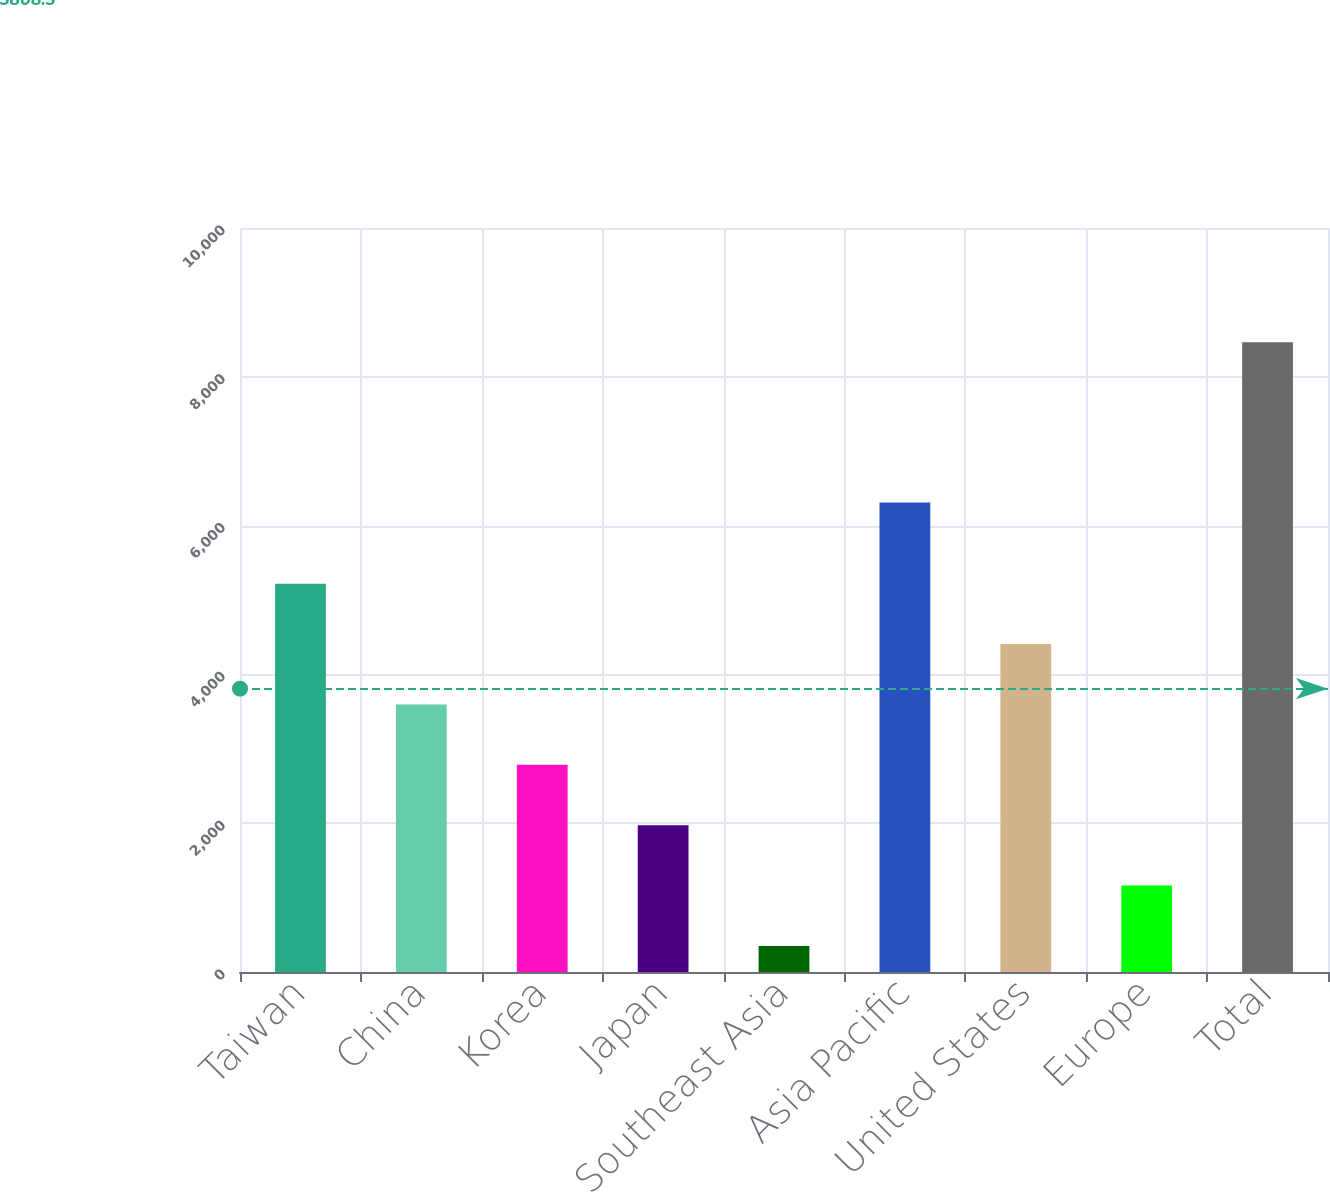Convert chart to OTSL. <chart><loc_0><loc_0><loc_500><loc_500><bar_chart><fcel>Taiwan<fcel>China<fcel>Korea<fcel>Japan<fcel>Southeast Asia<fcel>Asia Pacific<fcel>United States<fcel>Europe<fcel>Total<nl><fcel>5220<fcel>3597<fcel>2785.5<fcel>1974<fcel>351<fcel>6312<fcel>4408.5<fcel>1162.5<fcel>8466<nl></chart> 